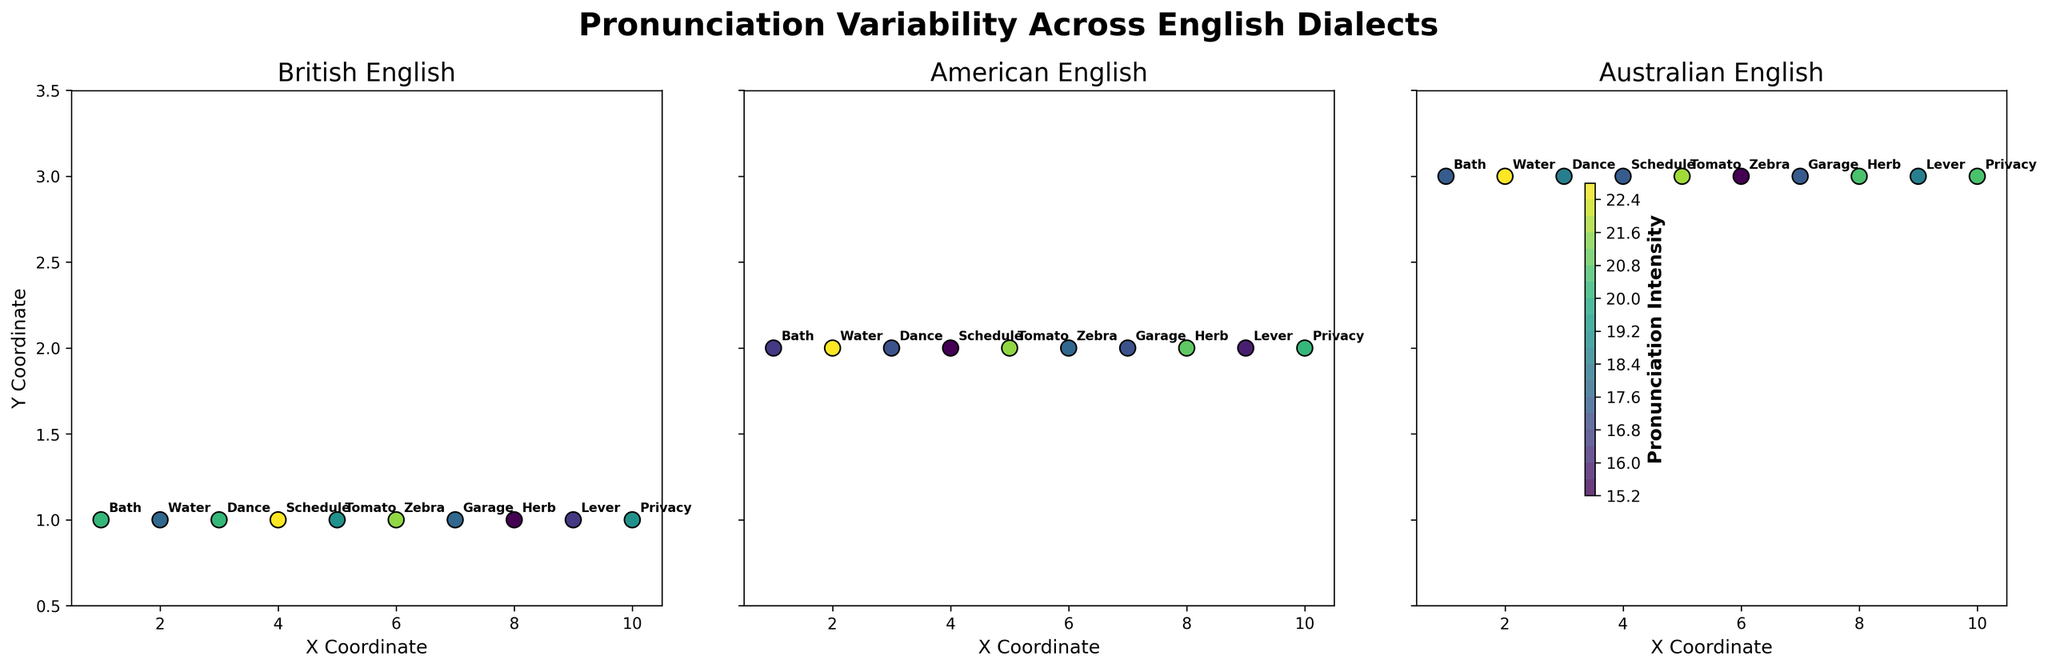What's the title of the figure? The title of the figure is usually located at the top and gives an overall description. Here, it says "Pronunciation Variability Across English Dialects".
Answer: Pronunciation Variability Across English Dialects In which dialect does the word ‘Bath’ have the highest pronunciation intensity? We need to look at the values of ‘Bath’ across the different dialects. The British dialect shows the highest value, which is 10.
Answer: British What is the range of the Y Coordinate axis? We need to look at the minimum and maximum values of the Y Coordinate axis along all subplots. The axis ranges from 0.5 to 3.5.
Answer: 0.5 to 3.5 Which word has the lowest pronunciation intensity in the American dialect? By looking at the contour and scatter points in the American subplot, the word 'Schedule' has the lowest intensity value which is 3.
Answer: Schedule Compare the pronunciation intensity of the word ‘Tomato’ in British and American dialects. Which one is higher? We compare the intensity values for 'Tomato' in both British (9) and American (13) dialects. The American dialect has a higher value.
Answer: American What is the average pronunciation intensity of 'Water' across all dialects? Sum the intensity values for 'Water' in British (8), American (15), and Australian (12) dialects, and then divide by the number of dialects (3). (8 + 15 + 12) / 3 = 35 / 3 = 11.67.
Answer: 11.67 Which dialect has the highest overall pronunciation intensity for the word ‘Dance’? Compare the intensity values for 'Dance': British (10), American (6), and Australian (8). The British dialect has the highest value, which is 10.
Answer: British In the Australian dialect, which word has the second-highest pronunciation intensity? Looking at the Australian subplot for distinct intensity values, the highest is ‘Water’ (12), followed by 'Tomato' (11).
Answer: Tomato 